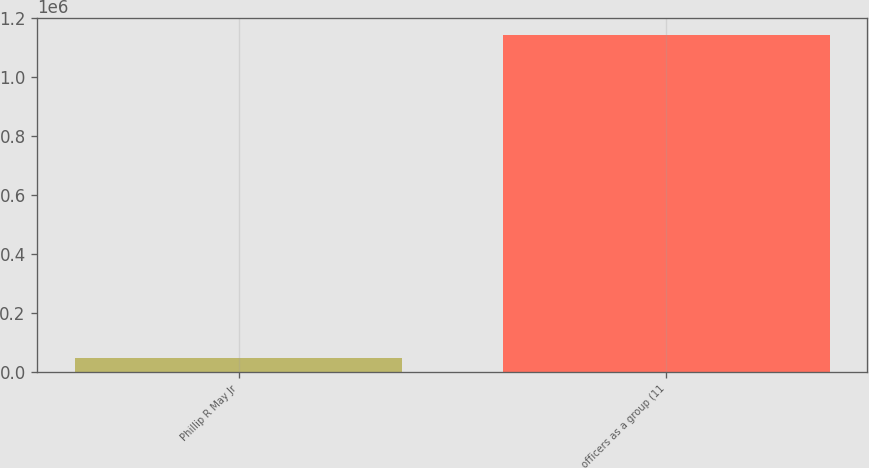Convert chart. <chart><loc_0><loc_0><loc_500><loc_500><bar_chart><fcel>Phillip R May Jr<fcel>officers as a group (11<nl><fcel>45233<fcel>1.14313e+06<nl></chart> 